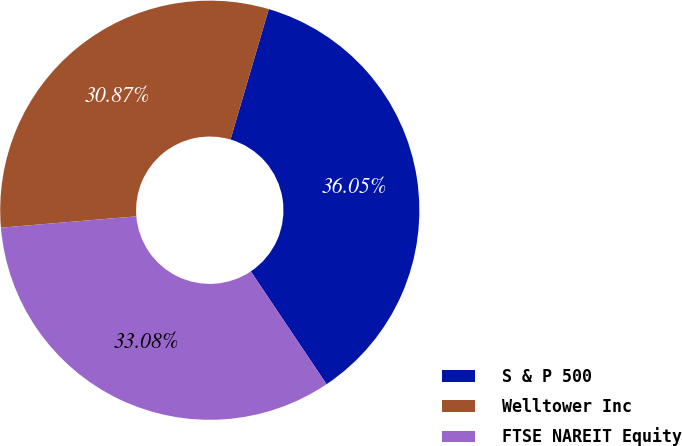<chart> <loc_0><loc_0><loc_500><loc_500><pie_chart><fcel>S & P 500<fcel>Welltower Inc<fcel>FTSE NAREIT Equity<nl><fcel>36.05%<fcel>30.87%<fcel>33.08%<nl></chart> 